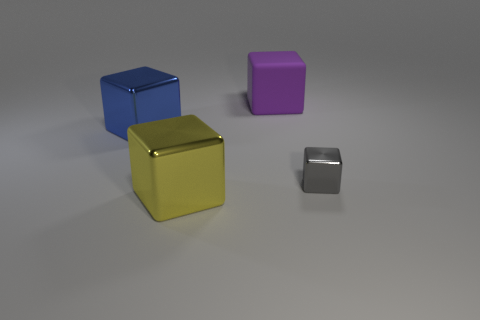What number of other things are there of the same size as the gray metal block?
Your answer should be very brief. 0. There is a shiny object that is right of the big yellow block; does it have the same shape as the blue thing on the left side of the gray thing?
Offer a very short reply. Yes. What number of things are either metallic spheres or shiny things that are left of the purple matte block?
Your answer should be compact. 2. There is a object that is both behind the gray thing and in front of the big purple object; what is its material?
Offer a very short reply. Metal. Are there any other things that have the same shape as the small gray object?
Provide a short and direct response. Yes. The big object that is the same material as the yellow block is what color?
Give a very brief answer. Blue. What number of objects are small gray metallic things or tiny yellow matte cubes?
Give a very brief answer. 1. Is the size of the matte thing the same as the block on the right side of the purple matte thing?
Give a very brief answer. No. What is the color of the object that is in front of the metallic thing that is right of the big metallic object in front of the large blue metal thing?
Your answer should be very brief. Yellow. The big matte cube is what color?
Your answer should be compact. Purple. 